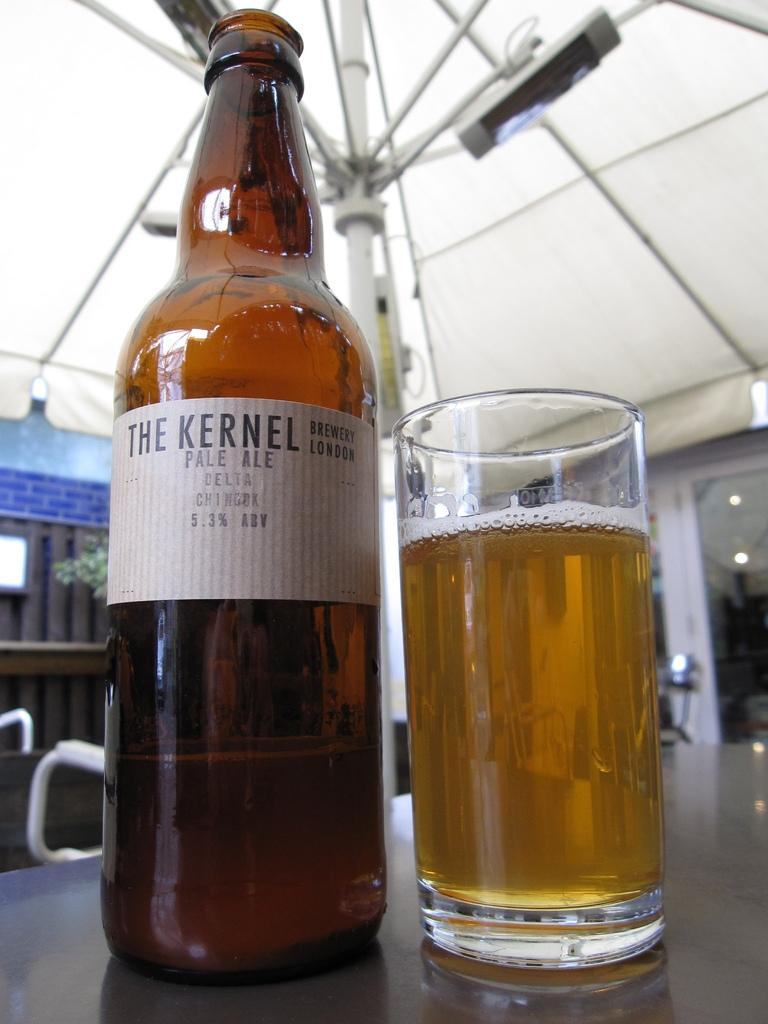<image>
Present a compact description of the photo's key features. Glass of beer next to a "The Kernel" beer bottle. 